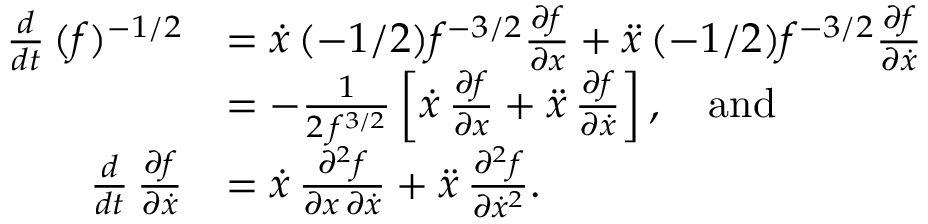<formula> <loc_0><loc_0><loc_500><loc_500>\begin{array} { r l } { \frac { d } { d t } \, ( f ) ^ { - 1 / 2 } } & { = \dot { x } \, ( - 1 / 2 ) f ^ { - 3 / 2 } \frac { \partial f } { \partial x } + \ddot { x } \, ( - 1 / 2 ) f ^ { - 3 / 2 } \frac { \partial f } { \partial \dot { x } } } \\ & { = - \frac { 1 } { 2 \, f ^ { 3 / 2 } } \left [ \dot { x } \, \frac { \partial f } { \partial x } + \ddot { x } \, \frac { \partial f } { \partial \dot { x } } \right ] , \quad a n d } \\ { \frac { d } { d t } \, \frac { \partial f } { \partial \dot { x } } } & { = \dot { x } \, \frac { \partial ^ { 2 } f } { \partial x \, \partial \dot { x } } + \ddot { x } \, \frac { \partial ^ { 2 } f } { \partial \dot { x } ^ { 2 } } . } \end{array}</formula> 